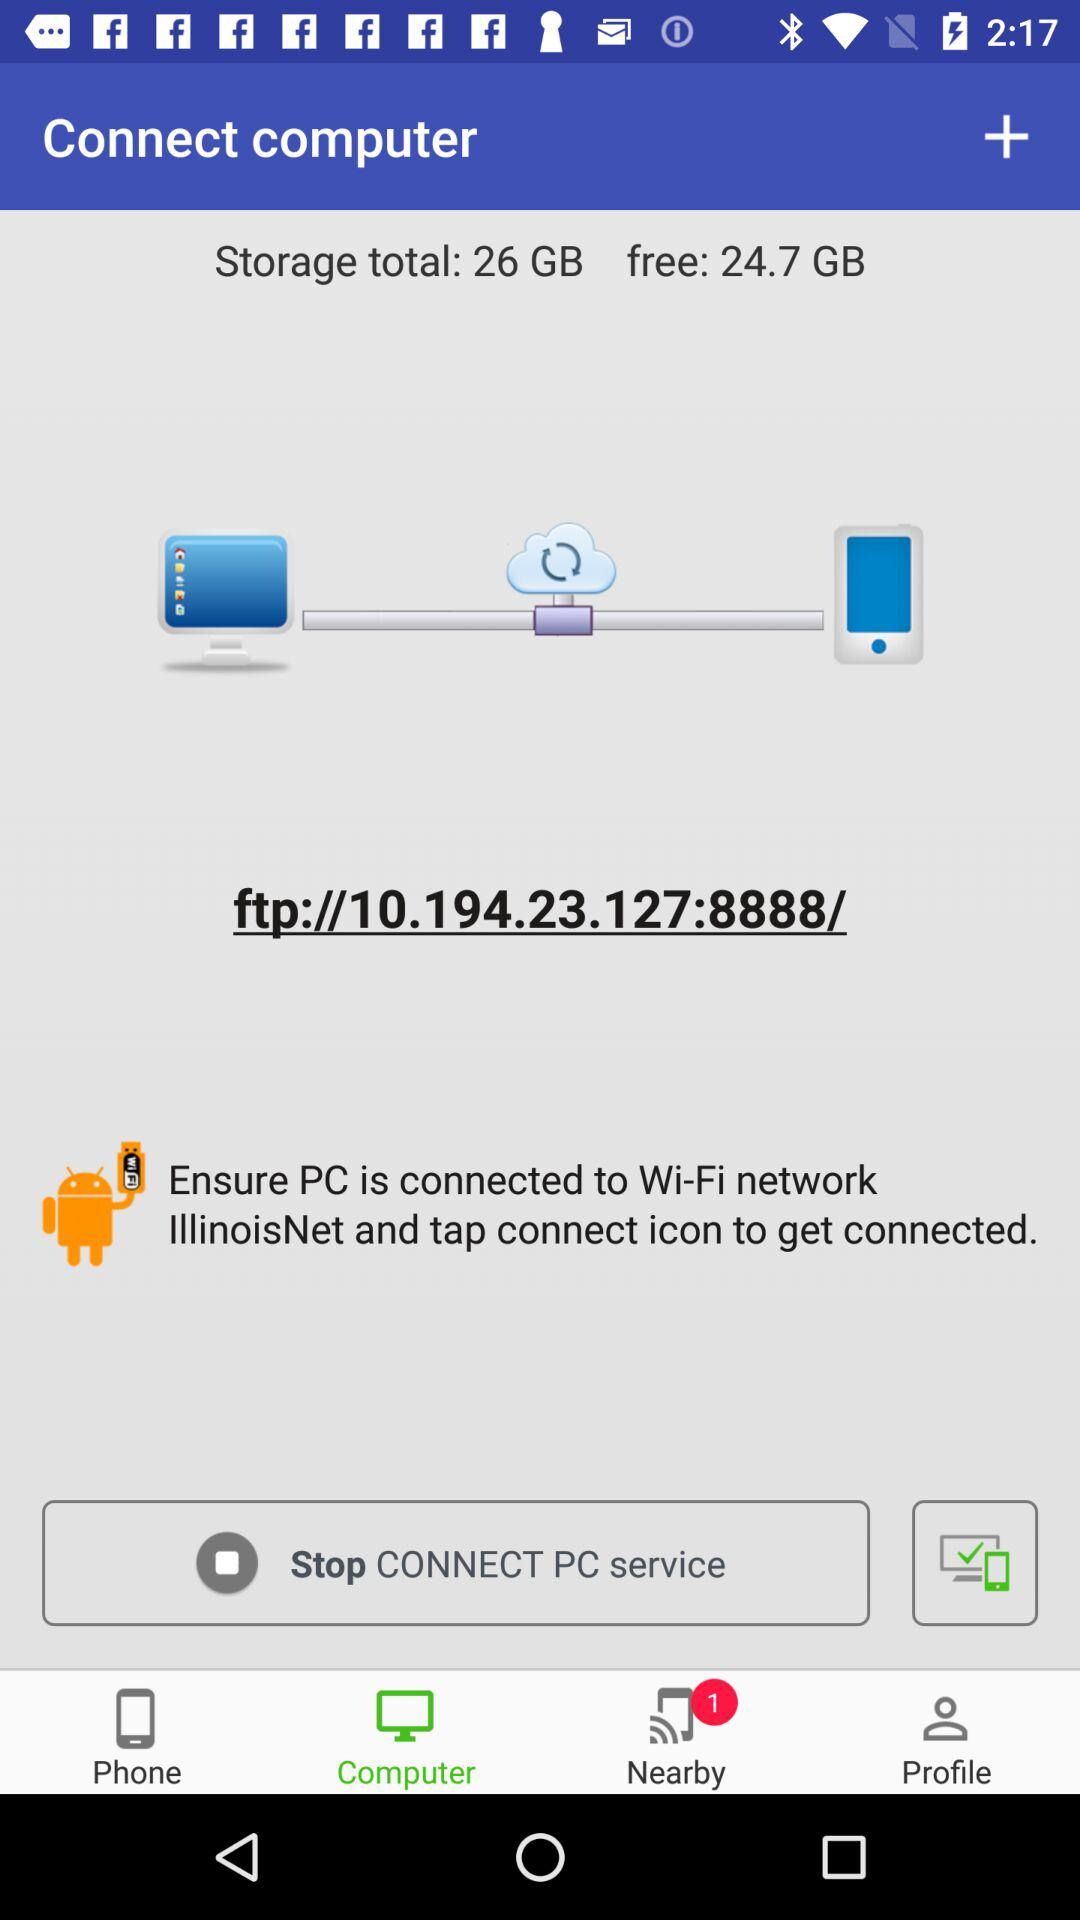How much storage is free? There is 24.7 GB of free storage. 